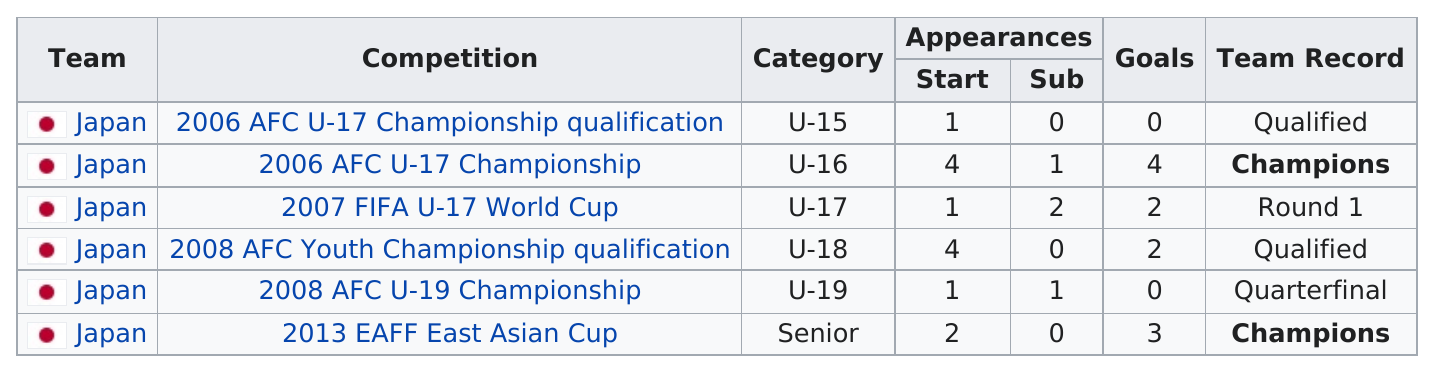Give some essential details in this illustration. The AFC U-17 Championship was the first competition to feature sub-units, which took place in 2006. In the 2006 AFC U-17 Championship qualification, Japan first qualified for competition. In the 2013 EAFF East Asian Cup, Japan had more starting appearances than in the 2007 FIFA U-17 World Cup. Ichiro Kakitani has scored more than two goals in major competitions, with a total of two goals. In total, 11 goals were scored. 